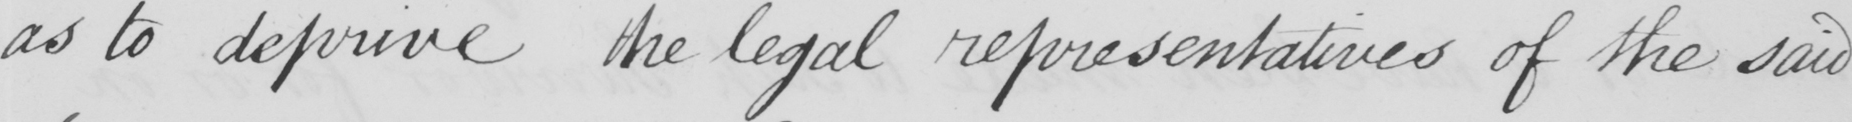What text is written in this handwritten line? as to deprive the legal representatives of the said 